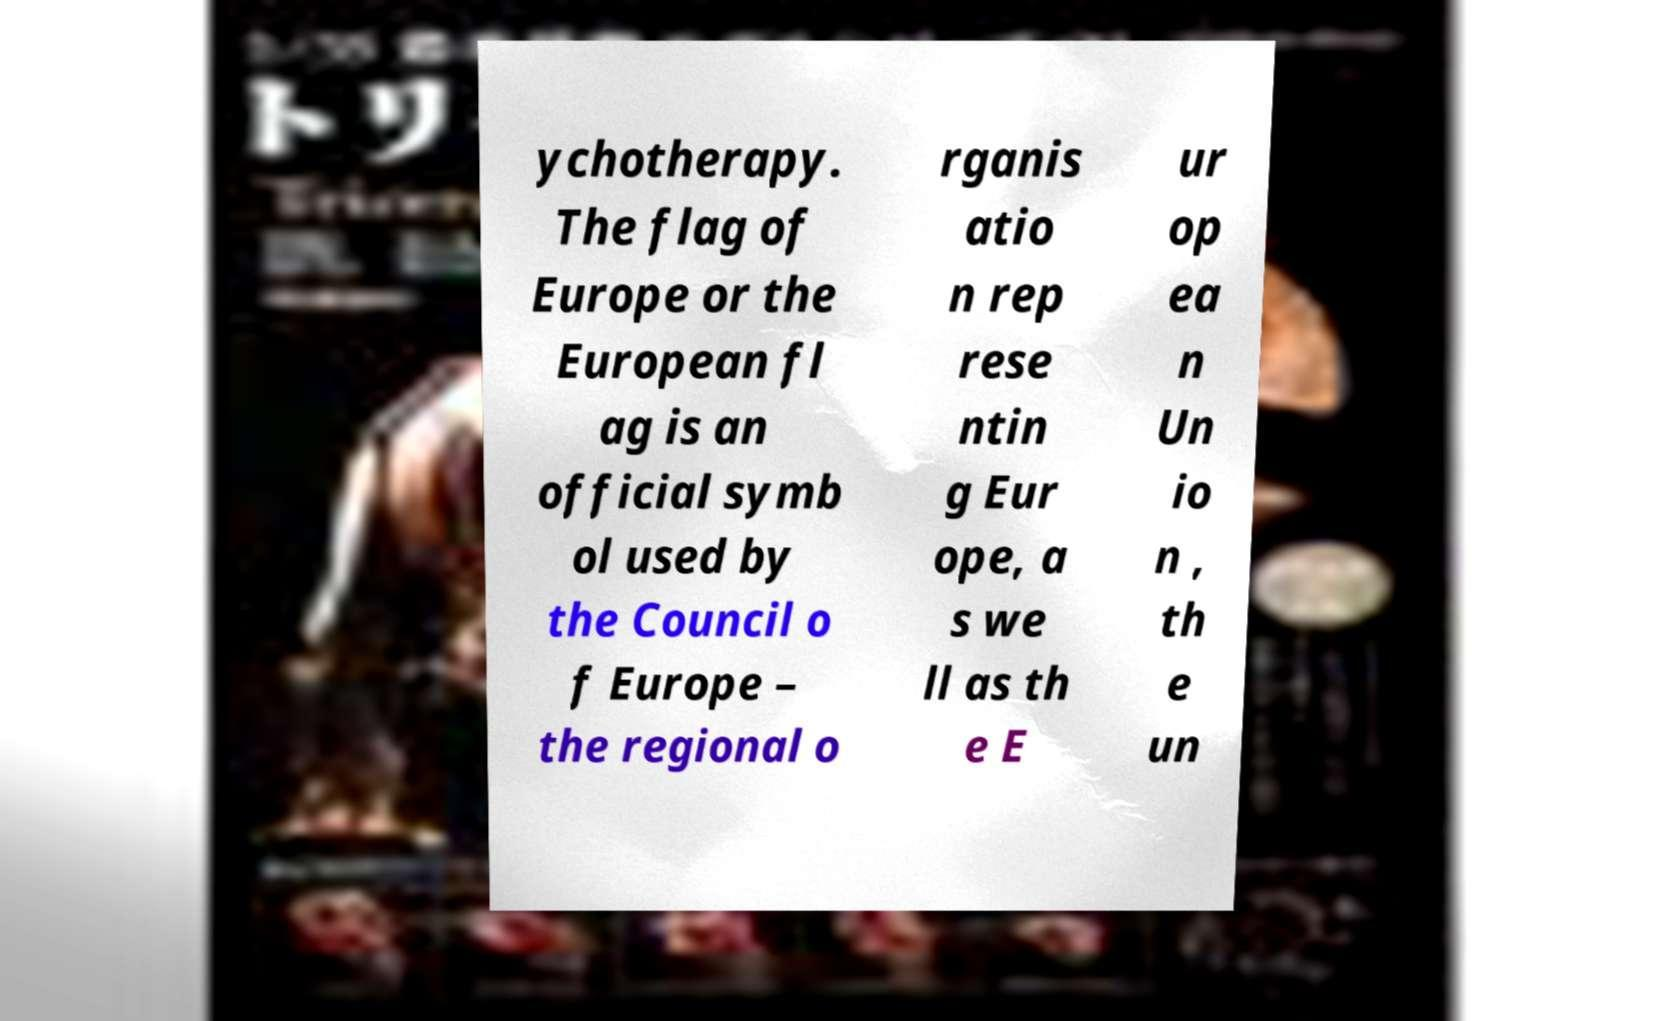There's text embedded in this image that I need extracted. Can you transcribe it verbatim? ychotherapy. The flag of Europe or the European fl ag is an official symb ol used by the Council o f Europe – the regional o rganis atio n rep rese ntin g Eur ope, a s we ll as th e E ur op ea n Un io n , th e un 